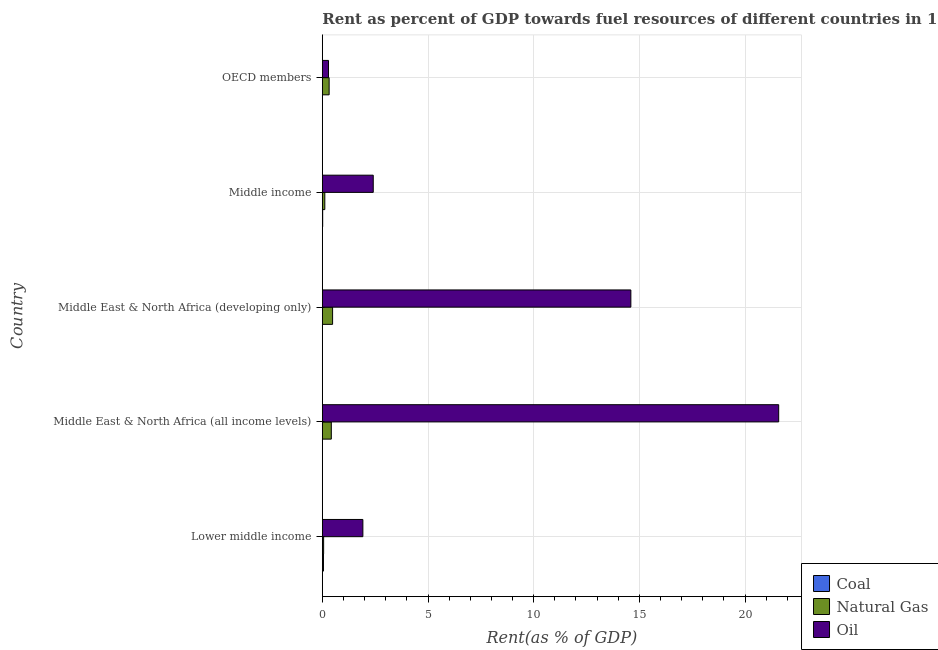How many different coloured bars are there?
Give a very brief answer. 3. Are the number of bars per tick equal to the number of legend labels?
Your answer should be very brief. Yes. What is the label of the 5th group of bars from the top?
Ensure brevity in your answer.  Lower middle income. In how many cases, is the number of bars for a given country not equal to the number of legend labels?
Give a very brief answer. 0. What is the rent towards natural gas in Middle East & North Africa (developing only)?
Make the answer very short. 0.49. Across all countries, what is the maximum rent towards oil?
Your answer should be compact. 21.59. Across all countries, what is the minimum rent towards coal?
Your answer should be very brief. 1.50641686702978e-6. In which country was the rent towards natural gas maximum?
Offer a very short reply. Middle East & North Africa (developing only). What is the total rent towards coal in the graph?
Give a very brief answer. 0.07. What is the difference between the rent towards natural gas in Middle East & North Africa (all income levels) and that in Middle East & North Africa (developing only)?
Keep it short and to the point. -0.06. What is the difference between the rent towards natural gas in OECD members and the rent towards coal in Lower middle income?
Your answer should be compact. 0.27. What is the average rent towards oil per country?
Provide a succinct answer. 8.16. In how many countries, is the rent towards oil greater than 10 %?
Your answer should be very brief. 2. What is the ratio of the rent towards natural gas in Lower middle income to that in Middle East & North Africa (developing only)?
Give a very brief answer. 0.13. Is the rent towards natural gas in Middle East & North Africa (all income levels) less than that in Middle East & North Africa (developing only)?
Offer a terse response. Yes. What is the difference between the highest and the second highest rent towards coal?
Ensure brevity in your answer.  0.04. What is the difference between the highest and the lowest rent towards coal?
Your answer should be compact. 0.05. In how many countries, is the rent towards oil greater than the average rent towards oil taken over all countries?
Your answer should be very brief. 2. What does the 1st bar from the top in Middle East & North Africa (developing only) represents?
Your answer should be compact. Oil. What does the 3rd bar from the bottom in Middle East & North Africa (all income levels) represents?
Keep it short and to the point. Oil. How many bars are there?
Your response must be concise. 15. Are all the bars in the graph horizontal?
Give a very brief answer. Yes. How many countries are there in the graph?
Provide a short and direct response. 5. What is the difference between two consecutive major ticks on the X-axis?
Your answer should be compact. 5. Does the graph contain any zero values?
Offer a terse response. No. Does the graph contain grids?
Keep it short and to the point. Yes. Where does the legend appear in the graph?
Make the answer very short. Bottom right. How many legend labels are there?
Make the answer very short. 3. How are the legend labels stacked?
Offer a very short reply. Vertical. What is the title of the graph?
Make the answer very short. Rent as percent of GDP towards fuel resources of different countries in 1973. Does "Secondary education" appear as one of the legend labels in the graph?
Ensure brevity in your answer.  No. What is the label or title of the X-axis?
Give a very brief answer. Rent(as % of GDP). What is the Rent(as % of GDP) of Coal in Lower middle income?
Give a very brief answer. 0.05. What is the Rent(as % of GDP) of Natural Gas in Lower middle income?
Your response must be concise. 0.06. What is the Rent(as % of GDP) of Oil in Lower middle income?
Your response must be concise. 1.92. What is the Rent(as % of GDP) of Coal in Middle East & North Africa (all income levels)?
Provide a short and direct response. 0. What is the Rent(as % of GDP) in Natural Gas in Middle East & North Africa (all income levels)?
Your answer should be compact. 0.43. What is the Rent(as % of GDP) of Oil in Middle East & North Africa (all income levels)?
Your answer should be very brief. 21.59. What is the Rent(as % of GDP) in Coal in Middle East & North Africa (developing only)?
Offer a very short reply. 0. What is the Rent(as % of GDP) in Natural Gas in Middle East & North Africa (developing only)?
Offer a very short reply. 0.49. What is the Rent(as % of GDP) of Oil in Middle East & North Africa (developing only)?
Keep it short and to the point. 14.6. What is the Rent(as % of GDP) in Coal in Middle income?
Your answer should be compact. 0.02. What is the Rent(as % of GDP) in Natural Gas in Middle income?
Your answer should be compact. 0.12. What is the Rent(as % of GDP) of Oil in Middle income?
Your answer should be very brief. 2.41. What is the Rent(as % of GDP) in Coal in OECD members?
Ensure brevity in your answer.  1.50641686702978e-6. What is the Rent(as % of GDP) in Natural Gas in OECD members?
Provide a succinct answer. 0.32. What is the Rent(as % of GDP) in Oil in OECD members?
Your answer should be compact. 0.29. Across all countries, what is the maximum Rent(as % of GDP) in Coal?
Offer a very short reply. 0.05. Across all countries, what is the maximum Rent(as % of GDP) of Natural Gas?
Provide a succinct answer. 0.49. Across all countries, what is the maximum Rent(as % of GDP) of Oil?
Your answer should be compact. 21.59. Across all countries, what is the minimum Rent(as % of GDP) in Coal?
Keep it short and to the point. 1.50641686702978e-6. Across all countries, what is the minimum Rent(as % of GDP) of Natural Gas?
Ensure brevity in your answer.  0.06. Across all countries, what is the minimum Rent(as % of GDP) in Oil?
Offer a very short reply. 0.29. What is the total Rent(as % of GDP) of Coal in the graph?
Provide a succinct answer. 0.07. What is the total Rent(as % of GDP) in Natural Gas in the graph?
Ensure brevity in your answer.  1.41. What is the total Rent(as % of GDP) in Oil in the graph?
Your response must be concise. 40.81. What is the difference between the Rent(as % of GDP) in Coal in Lower middle income and that in Middle East & North Africa (all income levels)?
Ensure brevity in your answer.  0.05. What is the difference between the Rent(as % of GDP) of Natural Gas in Lower middle income and that in Middle East & North Africa (all income levels)?
Provide a short and direct response. -0.36. What is the difference between the Rent(as % of GDP) of Oil in Lower middle income and that in Middle East & North Africa (all income levels)?
Provide a succinct answer. -19.67. What is the difference between the Rent(as % of GDP) in Coal in Lower middle income and that in Middle East & North Africa (developing only)?
Ensure brevity in your answer.  0.05. What is the difference between the Rent(as % of GDP) in Natural Gas in Lower middle income and that in Middle East & North Africa (developing only)?
Offer a terse response. -0.42. What is the difference between the Rent(as % of GDP) of Oil in Lower middle income and that in Middle East & North Africa (developing only)?
Give a very brief answer. -12.68. What is the difference between the Rent(as % of GDP) in Coal in Lower middle income and that in Middle income?
Offer a terse response. 0.04. What is the difference between the Rent(as % of GDP) of Natural Gas in Lower middle income and that in Middle income?
Your answer should be very brief. -0.06. What is the difference between the Rent(as % of GDP) of Oil in Lower middle income and that in Middle income?
Provide a short and direct response. -0.49. What is the difference between the Rent(as % of GDP) in Coal in Lower middle income and that in OECD members?
Ensure brevity in your answer.  0.05. What is the difference between the Rent(as % of GDP) in Natural Gas in Lower middle income and that in OECD members?
Make the answer very short. -0.26. What is the difference between the Rent(as % of GDP) in Oil in Lower middle income and that in OECD members?
Make the answer very short. 1.63. What is the difference between the Rent(as % of GDP) in Coal in Middle East & North Africa (all income levels) and that in Middle East & North Africa (developing only)?
Ensure brevity in your answer.  -0. What is the difference between the Rent(as % of GDP) of Natural Gas in Middle East & North Africa (all income levels) and that in Middle East & North Africa (developing only)?
Provide a succinct answer. -0.06. What is the difference between the Rent(as % of GDP) in Oil in Middle East & North Africa (all income levels) and that in Middle East & North Africa (developing only)?
Give a very brief answer. 6.99. What is the difference between the Rent(as % of GDP) of Coal in Middle East & North Africa (all income levels) and that in Middle income?
Make the answer very short. -0.02. What is the difference between the Rent(as % of GDP) in Natural Gas in Middle East & North Africa (all income levels) and that in Middle income?
Offer a terse response. 0.31. What is the difference between the Rent(as % of GDP) of Oil in Middle East & North Africa (all income levels) and that in Middle income?
Your response must be concise. 19.18. What is the difference between the Rent(as % of GDP) in Coal in Middle East & North Africa (all income levels) and that in OECD members?
Your answer should be compact. 0. What is the difference between the Rent(as % of GDP) of Natural Gas in Middle East & North Africa (all income levels) and that in OECD members?
Offer a very short reply. 0.1. What is the difference between the Rent(as % of GDP) in Oil in Middle East & North Africa (all income levels) and that in OECD members?
Your answer should be very brief. 21.3. What is the difference between the Rent(as % of GDP) in Coal in Middle East & North Africa (developing only) and that in Middle income?
Your answer should be very brief. -0.01. What is the difference between the Rent(as % of GDP) in Natural Gas in Middle East & North Africa (developing only) and that in Middle income?
Make the answer very short. 0.37. What is the difference between the Rent(as % of GDP) of Oil in Middle East & North Africa (developing only) and that in Middle income?
Provide a succinct answer. 12.19. What is the difference between the Rent(as % of GDP) of Coal in Middle East & North Africa (developing only) and that in OECD members?
Your answer should be compact. 0. What is the difference between the Rent(as % of GDP) of Natural Gas in Middle East & North Africa (developing only) and that in OECD members?
Ensure brevity in your answer.  0.16. What is the difference between the Rent(as % of GDP) in Oil in Middle East & North Africa (developing only) and that in OECD members?
Offer a very short reply. 14.3. What is the difference between the Rent(as % of GDP) of Coal in Middle income and that in OECD members?
Give a very brief answer. 0.02. What is the difference between the Rent(as % of GDP) in Natural Gas in Middle income and that in OECD members?
Your answer should be very brief. -0.2. What is the difference between the Rent(as % of GDP) in Oil in Middle income and that in OECD members?
Ensure brevity in your answer.  2.12. What is the difference between the Rent(as % of GDP) in Coal in Lower middle income and the Rent(as % of GDP) in Natural Gas in Middle East & North Africa (all income levels)?
Your response must be concise. -0.37. What is the difference between the Rent(as % of GDP) of Coal in Lower middle income and the Rent(as % of GDP) of Oil in Middle East & North Africa (all income levels)?
Give a very brief answer. -21.54. What is the difference between the Rent(as % of GDP) of Natural Gas in Lower middle income and the Rent(as % of GDP) of Oil in Middle East & North Africa (all income levels)?
Ensure brevity in your answer.  -21.53. What is the difference between the Rent(as % of GDP) of Coal in Lower middle income and the Rent(as % of GDP) of Natural Gas in Middle East & North Africa (developing only)?
Provide a succinct answer. -0.43. What is the difference between the Rent(as % of GDP) of Coal in Lower middle income and the Rent(as % of GDP) of Oil in Middle East & North Africa (developing only)?
Your answer should be compact. -14.54. What is the difference between the Rent(as % of GDP) in Natural Gas in Lower middle income and the Rent(as % of GDP) in Oil in Middle East & North Africa (developing only)?
Offer a very short reply. -14.54. What is the difference between the Rent(as % of GDP) of Coal in Lower middle income and the Rent(as % of GDP) of Natural Gas in Middle income?
Offer a terse response. -0.06. What is the difference between the Rent(as % of GDP) in Coal in Lower middle income and the Rent(as % of GDP) in Oil in Middle income?
Your answer should be very brief. -2.35. What is the difference between the Rent(as % of GDP) of Natural Gas in Lower middle income and the Rent(as % of GDP) of Oil in Middle income?
Make the answer very short. -2.35. What is the difference between the Rent(as % of GDP) of Coal in Lower middle income and the Rent(as % of GDP) of Natural Gas in OECD members?
Ensure brevity in your answer.  -0.27. What is the difference between the Rent(as % of GDP) in Coal in Lower middle income and the Rent(as % of GDP) in Oil in OECD members?
Offer a very short reply. -0.24. What is the difference between the Rent(as % of GDP) of Natural Gas in Lower middle income and the Rent(as % of GDP) of Oil in OECD members?
Give a very brief answer. -0.23. What is the difference between the Rent(as % of GDP) in Coal in Middle East & North Africa (all income levels) and the Rent(as % of GDP) in Natural Gas in Middle East & North Africa (developing only)?
Your response must be concise. -0.48. What is the difference between the Rent(as % of GDP) in Coal in Middle East & North Africa (all income levels) and the Rent(as % of GDP) in Oil in Middle East & North Africa (developing only)?
Offer a very short reply. -14.59. What is the difference between the Rent(as % of GDP) of Natural Gas in Middle East & North Africa (all income levels) and the Rent(as % of GDP) of Oil in Middle East & North Africa (developing only)?
Make the answer very short. -14.17. What is the difference between the Rent(as % of GDP) in Coal in Middle East & North Africa (all income levels) and the Rent(as % of GDP) in Natural Gas in Middle income?
Keep it short and to the point. -0.12. What is the difference between the Rent(as % of GDP) in Coal in Middle East & North Africa (all income levels) and the Rent(as % of GDP) in Oil in Middle income?
Ensure brevity in your answer.  -2.41. What is the difference between the Rent(as % of GDP) in Natural Gas in Middle East & North Africa (all income levels) and the Rent(as % of GDP) in Oil in Middle income?
Offer a very short reply. -1.98. What is the difference between the Rent(as % of GDP) of Coal in Middle East & North Africa (all income levels) and the Rent(as % of GDP) of Natural Gas in OECD members?
Ensure brevity in your answer.  -0.32. What is the difference between the Rent(as % of GDP) of Coal in Middle East & North Africa (all income levels) and the Rent(as % of GDP) of Oil in OECD members?
Your response must be concise. -0.29. What is the difference between the Rent(as % of GDP) of Natural Gas in Middle East & North Africa (all income levels) and the Rent(as % of GDP) of Oil in OECD members?
Keep it short and to the point. 0.13. What is the difference between the Rent(as % of GDP) of Coal in Middle East & North Africa (developing only) and the Rent(as % of GDP) of Natural Gas in Middle income?
Keep it short and to the point. -0.11. What is the difference between the Rent(as % of GDP) of Coal in Middle East & North Africa (developing only) and the Rent(as % of GDP) of Oil in Middle income?
Give a very brief answer. -2.41. What is the difference between the Rent(as % of GDP) in Natural Gas in Middle East & North Africa (developing only) and the Rent(as % of GDP) in Oil in Middle income?
Provide a short and direct response. -1.92. What is the difference between the Rent(as % of GDP) in Coal in Middle East & North Africa (developing only) and the Rent(as % of GDP) in Natural Gas in OECD members?
Provide a short and direct response. -0.32. What is the difference between the Rent(as % of GDP) of Coal in Middle East & North Africa (developing only) and the Rent(as % of GDP) of Oil in OECD members?
Your answer should be compact. -0.29. What is the difference between the Rent(as % of GDP) of Natural Gas in Middle East & North Africa (developing only) and the Rent(as % of GDP) of Oil in OECD members?
Ensure brevity in your answer.  0.19. What is the difference between the Rent(as % of GDP) in Coal in Middle income and the Rent(as % of GDP) in Natural Gas in OECD members?
Ensure brevity in your answer.  -0.31. What is the difference between the Rent(as % of GDP) in Coal in Middle income and the Rent(as % of GDP) in Oil in OECD members?
Offer a terse response. -0.27. What is the difference between the Rent(as % of GDP) of Natural Gas in Middle income and the Rent(as % of GDP) of Oil in OECD members?
Offer a terse response. -0.17. What is the average Rent(as % of GDP) of Coal per country?
Ensure brevity in your answer.  0.01. What is the average Rent(as % of GDP) of Natural Gas per country?
Offer a very short reply. 0.28. What is the average Rent(as % of GDP) of Oil per country?
Make the answer very short. 8.16. What is the difference between the Rent(as % of GDP) of Coal and Rent(as % of GDP) of Natural Gas in Lower middle income?
Keep it short and to the point. -0.01. What is the difference between the Rent(as % of GDP) in Coal and Rent(as % of GDP) in Oil in Lower middle income?
Provide a short and direct response. -1.86. What is the difference between the Rent(as % of GDP) of Natural Gas and Rent(as % of GDP) of Oil in Lower middle income?
Provide a succinct answer. -1.86. What is the difference between the Rent(as % of GDP) in Coal and Rent(as % of GDP) in Natural Gas in Middle East & North Africa (all income levels)?
Your answer should be compact. -0.42. What is the difference between the Rent(as % of GDP) of Coal and Rent(as % of GDP) of Oil in Middle East & North Africa (all income levels)?
Offer a terse response. -21.59. What is the difference between the Rent(as % of GDP) in Natural Gas and Rent(as % of GDP) in Oil in Middle East & North Africa (all income levels)?
Provide a short and direct response. -21.17. What is the difference between the Rent(as % of GDP) of Coal and Rent(as % of GDP) of Natural Gas in Middle East & North Africa (developing only)?
Your response must be concise. -0.48. What is the difference between the Rent(as % of GDP) of Coal and Rent(as % of GDP) of Oil in Middle East & North Africa (developing only)?
Ensure brevity in your answer.  -14.59. What is the difference between the Rent(as % of GDP) of Natural Gas and Rent(as % of GDP) of Oil in Middle East & North Africa (developing only)?
Your answer should be compact. -14.11. What is the difference between the Rent(as % of GDP) of Coal and Rent(as % of GDP) of Natural Gas in Middle income?
Provide a short and direct response. -0.1. What is the difference between the Rent(as % of GDP) of Coal and Rent(as % of GDP) of Oil in Middle income?
Ensure brevity in your answer.  -2.39. What is the difference between the Rent(as % of GDP) of Natural Gas and Rent(as % of GDP) of Oil in Middle income?
Make the answer very short. -2.29. What is the difference between the Rent(as % of GDP) in Coal and Rent(as % of GDP) in Natural Gas in OECD members?
Offer a very short reply. -0.32. What is the difference between the Rent(as % of GDP) of Coal and Rent(as % of GDP) of Oil in OECD members?
Ensure brevity in your answer.  -0.29. What is the difference between the Rent(as % of GDP) in Natural Gas and Rent(as % of GDP) in Oil in OECD members?
Your response must be concise. 0.03. What is the ratio of the Rent(as % of GDP) in Coal in Lower middle income to that in Middle East & North Africa (all income levels)?
Give a very brief answer. 31.03. What is the ratio of the Rent(as % of GDP) of Natural Gas in Lower middle income to that in Middle East & North Africa (all income levels)?
Make the answer very short. 0.14. What is the ratio of the Rent(as % of GDP) in Oil in Lower middle income to that in Middle East & North Africa (all income levels)?
Provide a short and direct response. 0.09. What is the ratio of the Rent(as % of GDP) of Coal in Lower middle income to that in Middle East & North Africa (developing only)?
Give a very brief answer. 20.83. What is the ratio of the Rent(as % of GDP) in Natural Gas in Lower middle income to that in Middle East & North Africa (developing only)?
Your response must be concise. 0.13. What is the ratio of the Rent(as % of GDP) of Oil in Lower middle income to that in Middle East & North Africa (developing only)?
Your response must be concise. 0.13. What is the ratio of the Rent(as % of GDP) in Coal in Lower middle income to that in Middle income?
Make the answer very short. 3.2. What is the ratio of the Rent(as % of GDP) in Natural Gas in Lower middle income to that in Middle income?
Keep it short and to the point. 0.52. What is the ratio of the Rent(as % of GDP) in Oil in Lower middle income to that in Middle income?
Provide a succinct answer. 0.8. What is the ratio of the Rent(as % of GDP) of Coal in Lower middle income to that in OECD members?
Ensure brevity in your answer.  3.57e+04. What is the ratio of the Rent(as % of GDP) in Natural Gas in Lower middle income to that in OECD members?
Your answer should be very brief. 0.19. What is the ratio of the Rent(as % of GDP) in Oil in Lower middle income to that in OECD members?
Offer a very short reply. 6.58. What is the ratio of the Rent(as % of GDP) in Coal in Middle East & North Africa (all income levels) to that in Middle East & North Africa (developing only)?
Keep it short and to the point. 0.67. What is the ratio of the Rent(as % of GDP) of Natural Gas in Middle East & North Africa (all income levels) to that in Middle East & North Africa (developing only)?
Ensure brevity in your answer.  0.87. What is the ratio of the Rent(as % of GDP) in Oil in Middle East & North Africa (all income levels) to that in Middle East & North Africa (developing only)?
Keep it short and to the point. 1.48. What is the ratio of the Rent(as % of GDP) in Coal in Middle East & North Africa (all income levels) to that in Middle income?
Make the answer very short. 0.1. What is the ratio of the Rent(as % of GDP) in Natural Gas in Middle East & North Africa (all income levels) to that in Middle income?
Make the answer very short. 3.63. What is the ratio of the Rent(as % of GDP) in Oil in Middle East & North Africa (all income levels) to that in Middle income?
Your answer should be compact. 8.96. What is the ratio of the Rent(as % of GDP) in Coal in Middle East & North Africa (all income levels) to that in OECD members?
Make the answer very short. 1150.38. What is the ratio of the Rent(as % of GDP) of Natural Gas in Middle East & North Africa (all income levels) to that in OECD members?
Offer a very short reply. 1.32. What is the ratio of the Rent(as % of GDP) of Oil in Middle East & North Africa (all income levels) to that in OECD members?
Offer a very short reply. 74.02. What is the ratio of the Rent(as % of GDP) of Coal in Middle East & North Africa (developing only) to that in Middle income?
Offer a terse response. 0.15. What is the ratio of the Rent(as % of GDP) of Natural Gas in Middle East & North Africa (developing only) to that in Middle income?
Ensure brevity in your answer.  4.14. What is the ratio of the Rent(as % of GDP) of Oil in Middle East & North Africa (developing only) to that in Middle income?
Your answer should be compact. 6.06. What is the ratio of the Rent(as % of GDP) of Coal in Middle East & North Africa (developing only) to that in OECD members?
Ensure brevity in your answer.  1714.17. What is the ratio of the Rent(as % of GDP) in Natural Gas in Middle East & North Africa (developing only) to that in OECD members?
Provide a short and direct response. 1.51. What is the ratio of the Rent(as % of GDP) in Oil in Middle East & North Africa (developing only) to that in OECD members?
Give a very brief answer. 50.04. What is the ratio of the Rent(as % of GDP) of Coal in Middle income to that in OECD members?
Make the answer very short. 1.12e+04. What is the ratio of the Rent(as % of GDP) of Natural Gas in Middle income to that in OECD members?
Your answer should be compact. 0.36. What is the ratio of the Rent(as % of GDP) of Oil in Middle income to that in OECD members?
Make the answer very short. 8.26. What is the difference between the highest and the second highest Rent(as % of GDP) of Coal?
Offer a very short reply. 0.04. What is the difference between the highest and the second highest Rent(as % of GDP) of Natural Gas?
Keep it short and to the point. 0.06. What is the difference between the highest and the second highest Rent(as % of GDP) of Oil?
Provide a succinct answer. 6.99. What is the difference between the highest and the lowest Rent(as % of GDP) of Coal?
Offer a very short reply. 0.05. What is the difference between the highest and the lowest Rent(as % of GDP) of Natural Gas?
Ensure brevity in your answer.  0.42. What is the difference between the highest and the lowest Rent(as % of GDP) of Oil?
Provide a succinct answer. 21.3. 